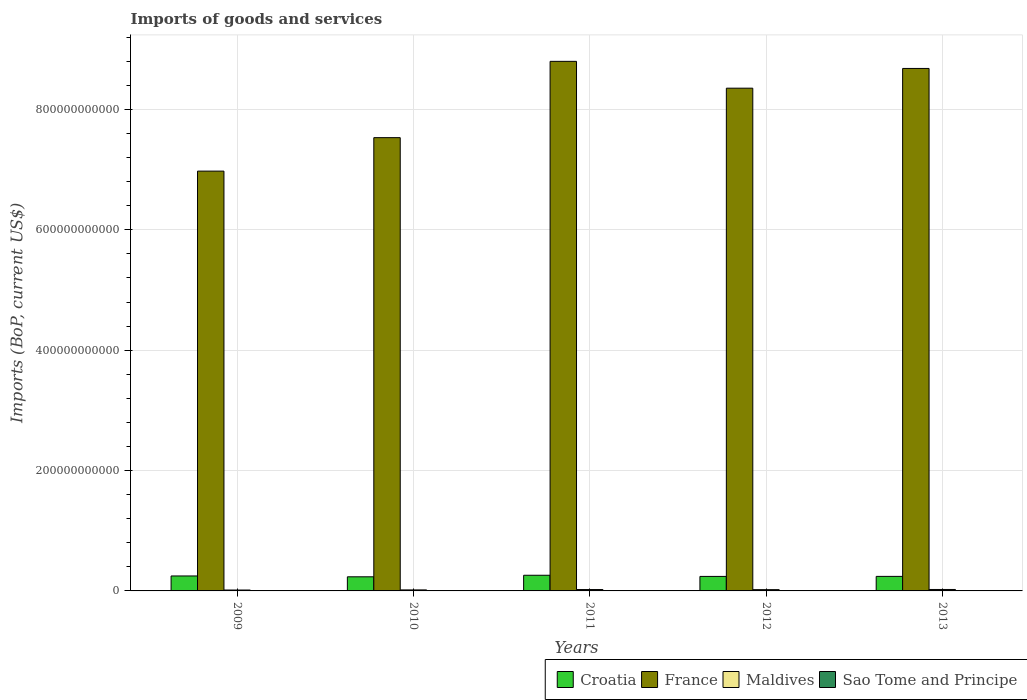How many different coloured bars are there?
Provide a short and direct response. 4. How many groups of bars are there?
Your response must be concise. 5. Are the number of bars per tick equal to the number of legend labels?
Your response must be concise. Yes. What is the label of the 3rd group of bars from the left?
Your response must be concise. 2011. In how many cases, is the number of bars for a given year not equal to the number of legend labels?
Make the answer very short. 0. What is the amount spent on imports in Croatia in 2011?
Offer a terse response. 2.60e+1. Across all years, what is the maximum amount spent on imports in Maldives?
Your answer should be very brief. 2.39e+09. Across all years, what is the minimum amount spent on imports in Sao Tome and Principe?
Make the answer very short. 1.03e+08. In which year was the amount spent on imports in Croatia minimum?
Ensure brevity in your answer.  2010. What is the total amount spent on imports in Croatia in the graph?
Ensure brevity in your answer.  1.23e+11. What is the difference between the amount spent on imports in Croatia in 2009 and that in 2011?
Provide a succinct answer. -1.18e+09. What is the difference between the amount spent on imports in Sao Tome and Principe in 2009 and the amount spent on imports in France in 2012?
Give a very brief answer. -8.35e+11. What is the average amount spent on imports in Sao Tome and Principe per year?
Give a very brief answer. 1.38e+08. In the year 2011, what is the difference between the amount spent on imports in France and amount spent on imports in Sao Tome and Principe?
Provide a succinct answer. 8.80e+11. In how many years, is the amount spent on imports in Croatia greater than 280000000000 US$?
Give a very brief answer. 0. What is the ratio of the amount spent on imports in Maldives in 2009 to that in 2011?
Your response must be concise. 0.64. What is the difference between the highest and the second highest amount spent on imports in Maldives?
Keep it short and to the point. 9.49e+07. What is the difference between the highest and the lowest amount spent on imports in Croatia?
Your answer should be very brief. 2.58e+09. What does the 4th bar from the right in 2012 represents?
Your answer should be compact. Croatia. Is it the case that in every year, the sum of the amount spent on imports in Croatia and amount spent on imports in France is greater than the amount spent on imports in Sao Tome and Principe?
Make the answer very short. Yes. How many bars are there?
Offer a very short reply. 20. Are all the bars in the graph horizontal?
Keep it short and to the point. No. What is the difference between two consecutive major ticks on the Y-axis?
Keep it short and to the point. 2.00e+11. Are the values on the major ticks of Y-axis written in scientific E-notation?
Offer a terse response. No. Does the graph contain grids?
Your response must be concise. Yes. How many legend labels are there?
Your response must be concise. 4. How are the legend labels stacked?
Provide a succinct answer. Horizontal. What is the title of the graph?
Ensure brevity in your answer.  Imports of goods and services. Does "Bangladesh" appear as one of the legend labels in the graph?
Provide a succinct answer. No. What is the label or title of the Y-axis?
Your answer should be compact. Imports (BoP, current US$). What is the Imports (BoP, current US$) of Croatia in 2009?
Provide a short and direct response. 2.48e+1. What is the Imports (BoP, current US$) in France in 2009?
Your answer should be compact. 6.97e+11. What is the Imports (BoP, current US$) of Maldives in 2009?
Your response must be concise. 1.48e+09. What is the Imports (BoP, current US$) of Sao Tome and Principe in 2009?
Offer a very short reply. 1.03e+08. What is the Imports (BoP, current US$) of Croatia in 2010?
Your answer should be compact. 2.34e+1. What is the Imports (BoP, current US$) of France in 2010?
Your answer should be compact. 7.53e+11. What is the Imports (BoP, current US$) in Maldives in 2010?
Provide a short and direct response. 1.69e+09. What is the Imports (BoP, current US$) in Sao Tome and Principe in 2010?
Your answer should be very brief. 1.21e+08. What is the Imports (BoP, current US$) in Croatia in 2011?
Ensure brevity in your answer.  2.60e+1. What is the Imports (BoP, current US$) of France in 2011?
Your answer should be very brief. 8.80e+11. What is the Imports (BoP, current US$) in Maldives in 2011?
Offer a very short reply. 2.30e+09. What is the Imports (BoP, current US$) of Sao Tome and Principe in 2011?
Ensure brevity in your answer.  1.47e+08. What is the Imports (BoP, current US$) of Croatia in 2012?
Provide a succinct answer. 2.41e+1. What is the Imports (BoP, current US$) in France in 2012?
Your response must be concise. 8.35e+11. What is the Imports (BoP, current US$) in Maldives in 2012?
Your answer should be very brief. 2.15e+09. What is the Imports (BoP, current US$) in Sao Tome and Principe in 2012?
Keep it short and to the point. 1.44e+08. What is the Imports (BoP, current US$) in Croatia in 2013?
Make the answer very short. 2.42e+1. What is the Imports (BoP, current US$) in France in 2013?
Make the answer very short. 8.68e+11. What is the Imports (BoP, current US$) in Maldives in 2013?
Your answer should be compact. 2.39e+09. What is the Imports (BoP, current US$) in Sao Tome and Principe in 2013?
Your answer should be compact. 1.74e+08. Across all years, what is the maximum Imports (BoP, current US$) in Croatia?
Keep it short and to the point. 2.60e+1. Across all years, what is the maximum Imports (BoP, current US$) of France?
Provide a short and direct response. 8.80e+11. Across all years, what is the maximum Imports (BoP, current US$) in Maldives?
Your answer should be compact. 2.39e+09. Across all years, what is the maximum Imports (BoP, current US$) of Sao Tome and Principe?
Give a very brief answer. 1.74e+08. Across all years, what is the minimum Imports (BoP, current US$) in Croatia?
Provide a succinct answer. 2.34e+1. Across all years, what is the minimum Imports (BoP, current US$) of France?
Make the answer very short. 6.97e+11. Across all years, what is the minimum Imports (BoP, current US$) of Maldives?
Give a very brief answer. 1.48e+09. Across all years, what is the minimum Imports (BoP, current US$) of Sao Tome and Principe?
Provide a short and direct response. 1.03e+08. What is the total Imports (BoP, current US$) of Croatia in the graph?
Your response must be concise. 1.23e+11. What is the total Imports (BoP, current US$) of France in the graph?
Provide a short and direct response. 4.03e+12. What is the total Imports (BoP, current US$) in Maldives in the graph?
Give a very brief answer. 1.00e+1. What is the total Imports (BoP, current US$) in Sao Tome and Principe in the graph?
Provide a short and direct response. 6.88e+08. What is the difference between the Imports (BoP, current US$) of Croatia in 2009 and that in 2010?
Your response must be concise. 1.40e+09. What is the difference between the Imports (BoP, current US$) of France in 2009 and that in 2010?
Provide a short and direct response. -5.56e+1. What is the difference between the Imports (BoP, current US$) in Maldives in 2009 and that in 2010?
Your answer should be very brief. -2.13e+08. What is the difference between the Imports (BoP, current US$) of Sao Tome and Principe in 2009 and that in 2010?
Provide a short and direct response. -1.78e+07. What is the difference between the Imports (BoP, current US$) of Croatia in 2009 and that in 2011?
Provide a succinct answer. -1.18e+09. What is the difference between the Imports (BoP, current US$) of France in 2009 and that in 2011?
Offer a very short reply. -1.82e+11. What is the difference between the Imports (BoP, current US$) of Maldives in 2009 and that in 2011?
Your answer should be compact. -8.18e+08. What is the difference between the Imports (BoP, current US$) of Sao Tome and Principe in 2009 and that in 2011?
Your answer should be compact. -4.43e+07. What is the difference between the Imports (BoP, current US$) in Croatia in 2009 and that in 2012?
Keep it short and to the point. 7.37e+08. What is the difference between the Imports (BoP, current US$) of France in 2009 and that in 2012?
Give a very brief answer. -1.38e+11. What is the difference between the Imports (BoP, current US$) of Maldives in 2009 and that in 2012?
Offer a terse response. -6.66e+08. What is the difference between the Imports (BoP, current US$) in Sao Tome and Principe in 2009 and that in 2012?
Your answer should be compact. -4.10e+07. What is the difference between the Imports (BoP, current US$) of Croatia in 2009 and that in 2013?
Provide a short and direct response. 6.98e+08. What is the difference between the Imports (BoP, current US$) in France in 2009 and that in 2013?
Your answer should be very brief. -1.71e+11. What is the difference between the Imports (BoP, current US$) in Maldives in 2009 and that in 2013?
Provide a succinct answer. -9.13e+08. What is the difference between the Imports (BoP, current US$) of Sao Tome and Principe in 2009 and that in 2013?
Keep it short and to the point. -7.08e+07. What is the difference between the Imports (BoP, current US$) of Croatia in 2010 and that in 2011?
Your response must be concise. -2.58e+09. What is the difference between the Imports (BoP, current US$) of France in 2010 and that in 2011?
Offer a very short reply. -1.27e+11. What is the difference between the Imports (BoP, current US$) of Maldives in 2010 and that in 2011?
Provide a succinct answer. -6.05e+08. What is the difference between the Imports (BoP, current US$) of Sao Tome and Principe in 2010 and that in 2011?
Offer a very short reply. -2.66e+07. What is the difference between the Imports (BoP, current US$) in Croatia in 2010 and that in 2012?
Provide a short and direct response. -6.66e+08. What is the difference between the Imports (BoP, current US$) of France in 2010 and that in 2012?
Offer a very short reply. -8.22e+1. What is the difference between the Imports (BoP, current US$) in Maldives in 2010 and that in 2012?
Your answer should be compact. -4.53e+08. What is the difference between the Imports (BoP, current US$) of Sao Tome and Principe in 2010 and that in 2012?
Offer a very short reply. -2.32e+07. What is the difference between the Imports (BoP, current US$) of Croatia in 2010 and that in 2013?
Provide a short and direct response. -7.05e+08. What is the difference between the Imports (BoP, current US$) in France in 2010 and that in 2013?
Give a very brief answer. -1.15e+11. What is the difference between the Imports (BoP, current US$) in Maldives in 2010 and that in 2013?
Your answer should be compact. -7.00e+08. What is the difference between the Imports (BoP, current US$) of Sao Tome and Principe in 2010 and that in 2013?
Ensure brevity in your answer.  -5.30e+07. What is the difference between the Imports (BoP, current US$) of Croatia in 2011 and that in 2012?
Ensure brevity in your answer.  1.91e+09. What is the difference between the Imports (BoP, current US$) in France in 2011 and that in 2012?
Your answer should be very brief. 4.46e+1. What is the difference between the Imports (BoP, current US$) of Maldives in 2011 and that in 2012?
Your response must be concise. 1.51e+08. What is the difference between the Imports (BoP, current US$) of Sao Tome and Principe in 2011 and that in 2012?
Offer a terse response. 3.32e+06. What is the difference between the Imports (BoP, current US$) in Croatia in 2011 and that in 2013?
Offer a very short reply. 1.87e+09. What is the difference between the Imports (BoP, current US$) in France in 2011 and that in 2013?
Offer a very short reply. 1.18e+1. What is the difference between the Imports (BoP, current US$) in Maldives in 2011 and that in 2013?
Your answer should be compact. -9.49e+07. What is the difference between the Imports (BoP, current US$) of Sao Tome and Principe in 2011 and that in 2013?
Offer a very short reply. -2.64e+07. What is the difference between the Imports (BoP, current US$) in Croatia in 2012 and that in 2013?
Keep it short and to the point. -3.94e+07. What is the difference between the Imports (BoP, current US$) in France in 2012 and that in 2013?
Offer a very short reply. -3.28e+1. What is the difference between the Imports (BoP, current US$) in Maldives in 2012 and that in 2013?
Provide a short and direct response. -2.46e+08. What is the difference between the Imports (BoP, current US$) in Sao Tome and Principe in 2012 and that in 2013?
Keep it short and to the point. -2.98e+07. What is the difference between the Imports (BoP, current US$) in Croatia in 2009 and the Imports (BoP, current US$) in France in 2010?
Offer a very short reply. -7.28e+11. What is the difference between the Imports (BoP, current US$) in Croatia in 2009 and the Imports (BoP, current US$) in Maldives in 2010?
Provide a short and direct response. 2.32e+1. What is the difference between the Imports (BoP, current US$) of Croatia in 2009 and the Imports (BoP, current US$) of Sao Tome and Principe in 2010?
Offer a terse response. 2.47e+1. What is the difference between the Imports (BoP, current US$) in France in 2009 and the Imports (BoP, current US$) in Maldives in 2010?
Your response must be concise. 6.96e+11. What is the difference between the Imports (BoP, current US$) in France in 2009 and the Imports (BoP, current US$) in Sao Tome and Principe in 2010?
Give a very brief answer. 6.97e+11. What is the difference between the Imports (BoP, current US$) in Maldives in 2009 and the Imports (BoP, current US$) in Sao Tome and Principe in 2010?
Your answer should be compact. 1.36e+09. What is the difference between the Imports (BoP, current US$) in Croatia in 2009 and the Imports (BoP, current US$) in France in 2011?
Your answer should be compact. -8.55e+11. What is the difference between the Imports (BoP, current US$) in Croatia in 2009 and the Imports (BoP, current US$) in Maldives in 2011?
Your response must be concise. 2.26e+1. What is the difference between the Imports (BoP, current US$) of Croatia in 2009 and the Imports (BoP, current US$) of Sao Tome and Principe in 2011?
Your answer should be compact. 2.47e+1. What is the difference between the Imports (BoP, current US$) in France in 2009 and the Imports (BoP, current US$) in Maldives in 2011?
Your answer should be very brief. 6.95e+11. What is the difference between the Imports (BoP, current US$) in France in 2009 and the Imports (BoP, current US$) in Sao Tome and Principe in 2011?
Give a very brief answer. 6.97e+11. What is the difference between the Imports (BoP, current US$) of Maldives in 2009 and the Imports (BoP, current US$) of Sao Tome and Principe in 2011?
Your answer should be very brief. 1.33e+09. What is the difference between the Imports (BoP, current US$) in Croatia in 2009 and the Imports (BoP, current US$) in France in 2012?
Keep it short and to the point. -8.10e+11. What is the difference between the Imports (BoP, current US$) of Croatia in 2009 and the Imports (BoP, current US$) of Maldives in 2012?
Your answer should be compact. 2.27e+1. What is the difference between the Imports (BoP, current US$) in Croatia in 2009 and the Imports (BoP, current US$) in Sao Tome and Principe in 2012?
Your answer should be compact. 2.47e+1. What is the difference between the Imports (BoP, current US$) in France in 2009 and the Imports (BoP, current US$) in Maldives in 2012?
Provide a succinct answer. 6.95e+11. What is the difference between the Imports (BoP, current US$) in France in 2009 and the Imports (BoP, current US$) in Sao Tome and Principe in 2012?
Your answer should be compact. 6.97e+11. What is the difference between the Imports (BoP, current US$) in Maldives in 2009 and the Imports (BoP, current US$) in Sao Tome and Principe in 2012?
Your response must be concise. 1.34e+09. What is the difference between the Imports (BoP, current US$) of Croatia in 2009 and the Imports (BoP, current US$) of France in 2013?
Make the answer very short. -8.43e+11. What is the difference between the Imports (BoP, current US$) of Croatia in 2009 and the Imports (BoP, current US$) of Maldives in 2013?
Offer a terse response. 2.25e+1. What is the difference between the Imports (BoP, current US$) in Croatia in 2009 and the Imports (BoP, current US$) in Sao Tome and Principe in 2013?
Make the answer very short. 2.47e+1. What is the difference between the Imports (BoP, current US$) of France in 2009 and the Imports (BoP, current US$) of Maldives in 2013?
Provide a short and direct response. 6.95e+11. What is the difference between the Imports (BoP, current US$) of France in 2009 and the Imports (BoP, current US$) of Sao Tome and Principe in 2013?
Ensure brevity in your answer.  6.97e+11. What is the difference between the Imports (BoP, current US$) of Maldives in 2009 and the Imports (BoP, current US$) of Sao Tome and Principe in 2013?
Ensure brevity in your answer.  1.31e+09. What is the difference between the Imports (BoP, current US$) of Croatia in 2010 and the Imports (BoP, current US$) of France in 2011?
Offer a very short reply. -8.56e+11. What is the difference between the Imports (BoP, current US$) in Croatia in 2010 and the Imports (BoP, current US$) in Maldives in 2011?
Offer a terse response. 2.11e+1. What is the difference between the Imports (BoP, current US$) of Croatia in 2010 and the Imports (BoP, current US$) of Sao Tome and Principe in 2011?
Your response must be concise. 2.33e+1. What is the difference between the Imports (BoP, current US$) of France in 2010 and the Imports (BoP, current US$) of Maldives in 2011?
Give a very brief answer. 7.51e+11. What is the difference between the Imports (BoP, current US$) of France in 2010 and the Imports (BoP, current US$) of Sao Tome and Principe in 2011?
Your answer should be compact. 7.53e+11. What is the difference between the Imports (BoP, current US$) of Maldives in 2010 and the Imports (BoP, current US$) of Sao Tome and Principe in 2011?
Ensure brevity in your answer.  1.55e+09. What is the difference between the Imports (BoP, current US$) of Croatia in 2010 and the Imports (BoP, current US$) of France in 2012?
Provide a short and direct response. -8.12e+11. What is the difference between the Imports (BoP, current US$) of Croatia in 2010 and the Imports (BoP, current US$) of Maldives in 2012?
Provide a short and direct response. 2.13e+1. What is the difference between the Imports (BoP, current US$) of Croatia in 2010 and the Imports (BoP, current US$) of Sao Tome and Principe in 2012?
Your answer should be very brief. 2.33e+1. What is the difference between the Imports (BoP, current US$) in France in 2010 and the Imports (BoP, current US$) in Maldives in 2012?
Offer a very short reply. 7.51e+11. What is the difference between the Imports (BoP, current US$) of France in 2010 and the Imports (BoP, current US$) of Sao Tome and Principe in 2012?
Make the answer very short. 7.53e+11. What is the difference between the Imports (BoP, current US$) in Maldives in 2010 and the Imports (BoP, current US$) in Sao Tome and Principe in 2012?
Ensure brevity in your answer.  1.55e+09. What is the difference between the Imports (BoP, current US$) in Croatia in 2010 and the Imports (BoP, current US$) in France in 2013?
Provide a short and direct response. -8.45e+11. What is the difference between the Imports (BoP, current US$) of Croatia in 2010 and the Imports (BoP, current US$) of Maldives in 2013?
Give a very brief answer. 2.11e+1. What is the difference between the Imports (BoP, current US$) in Croatia in 2010 and the Imports (BoP, current US$) in Sao Tome and Principe in 2013?
Give a very brief answer. 2.33e+1. What is the difference between the Imports (BoP, current US$) of France in 2010 and the Imports (BoP, current US$) of Maldives in 2013?
Your response must be concise. 7.51e+11. What is the difference between the Imports (BoP, current US$) of France in 2010 and the Imports (BoP, current US$) of Sao Tome and Principe in 2013?
Your answer should be very brief. 7.53e+11. What is the difference between the Imports (BoP, current US$) of Maldives in 2010 and the Imports (BoP, current US$) of Sao Tome and Principe in 2013?
Offer a terse response. 1.52e+09. What is the difference between the Imports (BoP, current US$) in Croatia in 2011 and the Imports (BoP, current US$) in France in 2012?
Your answer should be very brief. -8.09e+11. What is the difference between the Imports (BoP, current US$) in Croatia in 2011 and the Imports (BoP, current US$) in Maldives in 2012?
Provide a short and direct response. 2.39e+1. What is the difference between the Imports (BoP, current US$) in Croatia in 2011 and the Imports (BoP, current US$) in Sao Tome and Principe in 2012?
Ensure brevity in your answer.  2.59e+1. What is the difference between the Imports (BoP, current US$) of France in 2011 and the Imports (BoP, current US$) of Maldives in 2012?
Ensure brevity in your answer.  8.78e+11. What is the difference between the Imports (BoP, current US$) of France in 2011 and the Imports (BoP, current US$) of Sao Tome and Principe in 2012?
Your answer should be compact. 8.80e+11. What is the difference between the Imports (BoP, current US$) of Maldives in 2011 and the Imports (BoP, current US$) of Sao Tome and Principe in 2012?
Make the answer very short. 2.15e+09. What is the difference between the Imports (BoP, current US$) of Croatia in 2011 and the Imports (BoP, current US$) of France in 2013?
Your answer should be very brief. -8.42e+11. What is the difference between the Imports (BoP, current US$) in Croatia in 2011 and the Imports (BoP, current US$) in Maldives in 2013?
Provide a succinct answer. 2.36e+1. What is the difference between the Imports (BoP, current US$) in Croatia in 2011 and the Imports (BoP, current US$) in Sao Tome and Principe in 2013?
Ensure brevity in your answer.  2.59e+1. What is the difference between the Imports (BoP, current US$) of France in 2011 and the Imports (BoP, current US$) of Maldives in 2013?
Provide a short and direct response. 8.77e+11. What is the difference between the Imports (BoP, current US$) of France in 2011 and the Imports (BoP, current US$) of Sao Tome and Principe in 2013?
Provide a succinct answer. 8.80e+11. What is the difference between the Imports (BoP, current US$) in Maldives in 2011 and the Imports (BoP, current US$) in Sao Tome and Principe in 2013?
Your response must be concise. 2.12e+09. What is the difference between the Imports (BoP, current US$) in Croatia in 2012 and the Imports (BoP, current US$) in France in 2013?
Offer a very short reply. -8.44e+11. What is the difference between the Imports (BoP, current US$) of Croatia in 2012 and the Imports (BoP, current US$) of Maldives in 2013?
Your answer should be very brief. 2.17e+1. What is the difference between the Imports (BoP, current US$) in Croatia in 2012 and the Imports (BoP, current US$) in Sao Tome and Principe in 2013?
Keep it short and to the point. 2.39e+1. What is the difference between the Imports (BoP, current US$) in France in 2012 and the Imports (BoP, current US$) in Maldives in 2013?
Offer a terse response. 8.33e+11. What is the difference between the Imports (BoP, current US$) in France in 2012 and the Imports (BoP, current US$) in Sao Tome and Principe in 2013?
Your answer should be very brief. 8.35e+11. What is the difference between the Imports (BoP, current US$) of Maldives in 2012 and the Imports (BoP, current US$) of Sao Tome and Principe in 2013?
Offer a terse response. 1.97e+09. What is the average Imports (BoP, current US$) of Croatia per year?
Your answer should be very brief. 2.45e+1. What is the average Imports (BoP, current US$) in France per year?
Give a very brief answer. 8.07e+11. What is the average Imports (BoP, current US$) of Maldives per year?
Give a very brief answer. 2.00e+09. What is the average Imports (BoP, current US$) in Sao Tome and Principe per year?
Give a very brief answer. 1.38e+08. In the year 2009, what is the difference between the Imports (BoP, current US$) of Croatia and Imports (BoP, current US$) of France?
Provide a short and direct response. -6.73e+11. In the year 2009, what is the difference between the Imports (BoP, current US$) in Croatia and Imports (BoP, current US$) in Maldives?
Keep it short and to the point. 2.34e+1. In the year 2009, what is the difference between the Imports (BoP, current US$) in Croatia and Imports (BoP, current US$) in Sao Tome and Principe?
Keep it short and to the point. 2.47e+1. In the year 2009, what is the difference between the Imports (BoP, current US$) of France and Imports (BoP, current US$) of Maldives?
Ensure brevity in your answer.  6.96e+11. In the year 2009, what is the difference between the Imports (BoP, current US$) of France and Imports (BoP, current US$) of Sao Tome and Principe?
Keep it short and to the point. 6.97e+11. In the year 2009, what is the difference between the Imports (BoP, current US$) in Maldives and Imports (BoP, current US$) in Sao Tome and Principe?
Your response must be concise. 1.38e+09. In the year 2010, what is the difference between the Imports (BoP, current US$) in Croatia and Imports (BoP, current US$) in France?
Make the answer very short. -7.30e+11. In the year 2010, what is the difference between the Imports (BoP, current US$) in Croatia and Imports (BoP, current US$) in Maldives?
Offer a terse response. 2.18e+1. In the year 2010, what is the difference between the Imports (BoP, current US$) in Croatia and Imports (BoP, current US$) in Sao Tome and Principe?
Your answer should be very brief. 2.33e+1. In the year 2010, what is the difference between the Imports (BoP, current US$) in France and Imports (BoP, current US$) in Maldives?
Your answer should be very brief. 7.51e+11. In the year 2010, what is the difference between the Imports (BoP, current US$) of France and Imports (BoP, current US$) of Sao Tome and Principe?
Provide a succinct answer. 7.53e+11. In the year 2010, what is the difference between the Imports (BoP, current US$) of Maldives and Imports (BoP, current US$) of Sao Tome and Principe?
Provide a short and direct response. 1.57e+09. In the year 2011, what is the difference between the Imports (BoP, current US$) of Croatia and Imports (BoP, current US$) of France?
Provide a succinct answer. -8.54e+11. In the year 2011, what is the difference between the Imports (BoP, current US$) of Croatia and Imports (BoP, current US$) of Maldives?
Offer a very short reply. 2.37e+1. In the year 2011, what is the difference between the Imports (BoP, current US$) of Croatia and Imports (BoP, current US$) of Sao Tome and Principe?
Provide a short and direct response. 2.59e+1. In the year 2011, what is the difference between the Imports (BoP, current US$) in France and Imports (BoP, current US$) in Maldives?
Your answer should be very brief. 8.78e+11. In the year 2011, what is the difference between the Imports (BoP, current US$) in France and Imports (BoP, current US$) in Sao Tome and Principe?
Give a very brief answer. 8.80e+11. In the year 2011, what is the difference between the Imports (BoP, current US$) in Maldives and Imports (BoP, current US$) in Sao Tome and Principe?
Ensure brevity in your answer.  2.15e+09. In the year 2012, what is the difference between the Imports (BoP, current US$) of Croatia and Imports (BoP, current US$) of France?
Provide a succinct answer. -8.11e+11. In the year 2012, what is the difference between the Imports (BoP, current US$) in Croatia and Imports (BoP, current US$) in Maldives?
Ensure brevity in your answer.  2.20e+1. In the year 2012, what is the difference between the Imports (BoP, current US$) in Croatia and Imports (BoP, current US$) in Sao Tome and Principe?
Make the answer very short. 2.40e+1. In the year 2012, what is the difference between the Imports (BoP, current US$) of France and Imports (BoP, current US$) of Maldives?
Your response must be concise. 8.33e+11. In the year 2012, what is the difference between the Imports (BoP, current US$) of France and Imports (BoP, current US$) of Sao Tome and Principe?
Ensure brevity in your answer.  8.35e+11. In the year 2012, what is the difference between the Imports (BoP, current US$) of Maldives and Imports (BoP, current US$) of Sao Tome and Principe?
Give a very brief answer. 2.00e+09. In the year 2013, what is the difference between the Imports (BoP, current US$) of Croatia and Imports (BoP, current US$) of France?
Offer a terse response. -8.44e+11. In the year 2013, what is the difference between the Imports (BoP, current US$) in Croatia and Imports (BoP, current US$) in Maldives?
Make the answer very short. 2.18e+1. In the year 2013, what is the difference between the Imports (BoP, current US$) of Croatia and Imports (BoP, current US$) of Sao Tome and Principe?
Offer a very short reply. 2.40e+1. In the year 2013, what is the difference between the Imports (BoP, current US$) in France and Imports (BoP, current US$) in Maldives?
Give a very brief answer. 8.66e+11. In the year 2013, what is the difference between the Imports (BoP, current US$) of France and Imports (BoP, current US$) of Sao Tome and Principe?
Keep it short and to the point. 8.68e+11. In the year 2013, what is the difference between the Imports (BoP, current US$) in Maldives and Imports (BoP, current US$) in Sao Tome and Principe?
Ensure brevity in your answer.  2.22e+09. What is the ratio of the Imports (BoP, current US$) of Croatia in 2009 to that in 2010?
Give a very brief answer. 1.06. What is the ratio of the Imports (BoP, current US$) of France in 2009 to that in 2010?
Offer a terse response. 0.93. What is the ratio of the Imports (BoP, current US$) in Maldives in 2009 to that in 2010?
Your answer should be very brief. 0.87. What is the ratio of the Imports (BoP, current US$) of Sao Tome and Principe in 2009 to that in 2010?
Provide a succinct answer. 0.85. What is the ratio of the Imports (BoP, current US$) of Croatia in 2009 to that in 2011?
Offer a terse response. 0.95. What is the ratio of the Imports (BoP, current US$) of France in 2009 to that in 2011?
Your response must be concise. 0.79. What is the ratio of the Imports (BoP, current US$) of Maldives in 2009 to that in 2011?
Provide a succinct answer. 0.64. What is the ratio of the Imports (BoP, current US$) of Sao Tome and Principe in 2009 to that in 2011?
Make the answer very short. 0.7. What is the ratio of the Imports (BoP, current US$) in Croatia in 2009 to that in 2012?
Provide a short and direct response. 1.03. What is the ratio of the Imports (BoP, current US$) in France in 2009 to that in 2012?
Offer a terse response. 0.83. What is the ratio of the Imports (BoP, current US$) in Maldives in 2009 to that in 2012?
Provide a succinct answer. 0.69. What is the ratio of the Imports (BoP, current US$) in Sao Tome and Principe in 2009 to that in 2012?
Ensure brevity in your answer.  0.71. What is the ratio of the Imports (BoP, current US$) of Croatia in 2009 to that in 2013?
Offer a terse response. 1.03. What is the ratio of the Imports (BoP, current US$) of France in 2009 to that in 2013?
Keep it short and to the point. 0.8. What is the ratio of the Imports (BoP, current US$) of Maldives in 2009 to that in 2013?
Ensure brevity in your answer.  0.62. What is the ratio of the Imports (BoP, current US$) in Sao Tome and Principe in 2009 to that in 2013?
Offer a terse response. 0.59. What is the ratio of the Imports (BoP, current US$) of Croatia in 2010 to that in 2011?
Provide a short and direct response. 0.9. What is the ratio of the Imports (BoP, current US$) in France in 2010 to that in 2011?
Give a very brief answer. 0.86. What is the ratio of the Imports (BoP, current US$) in Maldives in 2010 to that in 2011?
Provide a succinct answer. 0.74. What is the ratio of the Imports (BoP, current US$) of Sao Tome and Principe in 2010 to that in 2011?
Your answer should be very brief. 0.82. What is the ratio of the Imports (BoP, current US$) in Croatia in 2010 to that in 2012?
Provide a succinct answer. 0.97. What is the ratio of the Imports (BoP, current US$) in France in 2010 to that in 2012?
Make the answer very short. 0.9. What is the ratio of the Imports (BoP, current US$) of Maldives in 2010 to that in 2012?
Your answer should be compact. 0.79. What is the ratio of the Imports (BoP, current US$) in Sao Tome and Principe in 2010 to that in 2012?
Offer a very short reply. 0.84. What is the ratio of the Imports (BoP, current US$) in Croatia in 2010 to that in 2013?
Offer a terse response. 0.97. What is the ratio of the Imports (BoP, current US$) in France in 2010 to that in 2013?
Your response must be concise. 0.87. What is the ratio of the Imports (BoP, current US$) in Maldives in 2010 to that in 2013?
Provide a succinct answer. 0.71. What is the ratio of the Imports (BoP, current US$) in Sao Tome and Principe in 2010 to that in 2013?
Keep it short and to the point. 0.69. What is the ratio of the Imports (BoP, current US$) of Croatia in 2011 to that in 2012?
Your answer should be compact. 1.08. What is the ratio of the Imports (BoP, current US$) in France in 2011 to that in 2012?
Keep it short and to the point. 1.05. What is the ratio of the Imports (BoP, current US$) of Maldives in 2011 to that in 2012?
Your response must be concise. 1.07. What is the ratio of the Imports (BoP, current US$) of Sao Tome and Principe in 2011 to that in 2012?
Ensure brevity in your answer.  1.02. What is the ratio of the Imports (BoP, current US$) of Croatia in 2011 to that in 2013?
Make the answer very short. 1.08. What is the ratio of the Imports (BoP, current US$) of France in 2011 to that in 2013?
Offer a very short reply. 1.01. What is the ratio of the Imports (BoP, current US$) in Maldives in 2011 to that in 2013?
Your response must be concise. 0.96. What is the ratio of the Imports (BoP, current US$) in Sao Tome and Principe in 2011 to that in 2013?
Provide a succinct answer. 0.85. What is the ratio of the Imports (BoP, current US$) in Croatia in 2012 to that in 2013?
Provide a short and direct response. 1. What is the ratio of the Imports (BoP, current US$) in France in 2012 to that in 2013?
Ensure brevity in your answer.  0.96. What is the ratio of the Imports (BoP, current US$) in Maldives in 2012 to that in 2013?
Make the answer very short. 0.9. What is the ratio of the Imports (BoP, current US$) in Sao Tome and Principe in 2012 to that in 2013?
Your response must be concise. 0.83. What is the difference between the highest and the second highest Imports (BoP, current US$) in Croatia?
Make the answer very short. 1.18e+09. What is the difference between the highest and the second highest Imports (BoP, current US$) in France?
Your response must be concise. 1.18e+1. What is the difference between the highest and the second highest Imports (BoP, current US$) of Maldives?
Ensure brevity in your answer.  9.49e+07. What is the difference between the highest and the second highest Imports (BoP, current US$) of Sao Tome and Principe?
Offer a very short reply. 2.64e+07. What is the difference between the highest and the lowest Imports (BoP, current US$) in Croatia?
Your response must be concise. 2.58e+09. What is the difference between the highest and the lowest Imports (BoP, current US$) in France?
Make the answer very short. 1.82e+11. What is the difference between the highest and the lowest Imports (BoP, current US$) in Maldives?
Keep it short and to the point. 9.13e+08. What is the difference between the highest and the lowest Imports (BoP, current US$) in Sao Tome and Principe?
Your answer should be compact. 7.08e+07. 